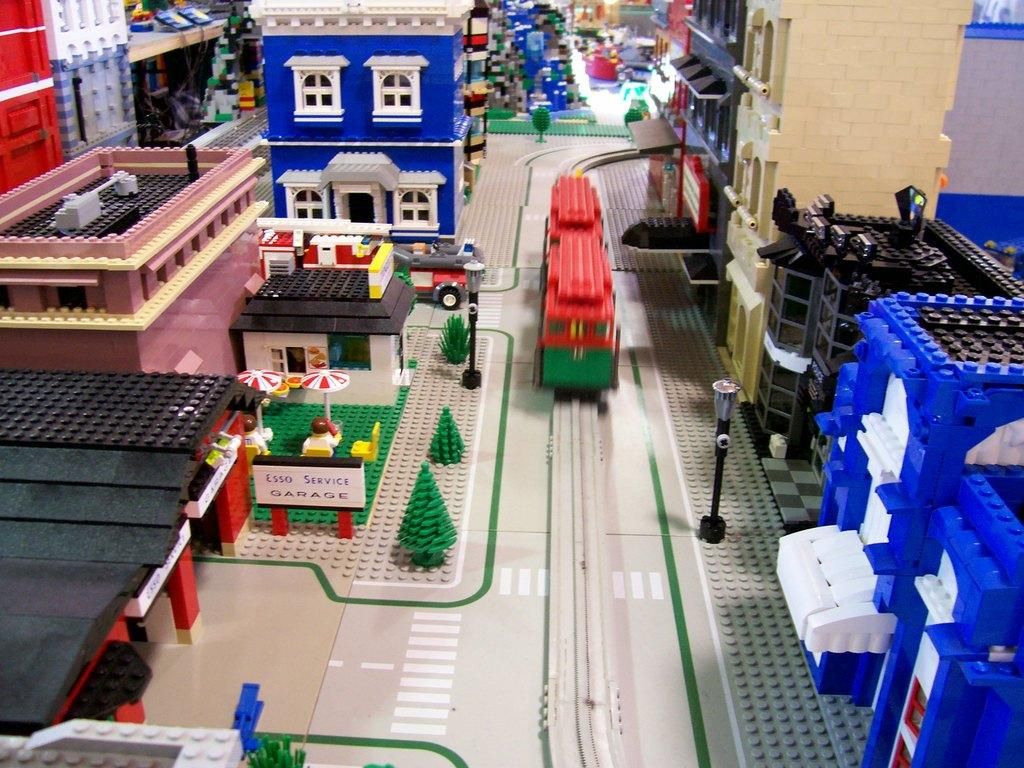What type of structures are present in the image? The image contains miniature buildings. What other elements can be seen in the image besides the buildings? There are trees and vehicles in the image. How are the elements in the image designed? The elements are made with Lego and are multi-colored. What type of account is being discussed in the image? There is no account being discussed in the image; it features miniature buildings, trees, vehicles, and Lego elements. 